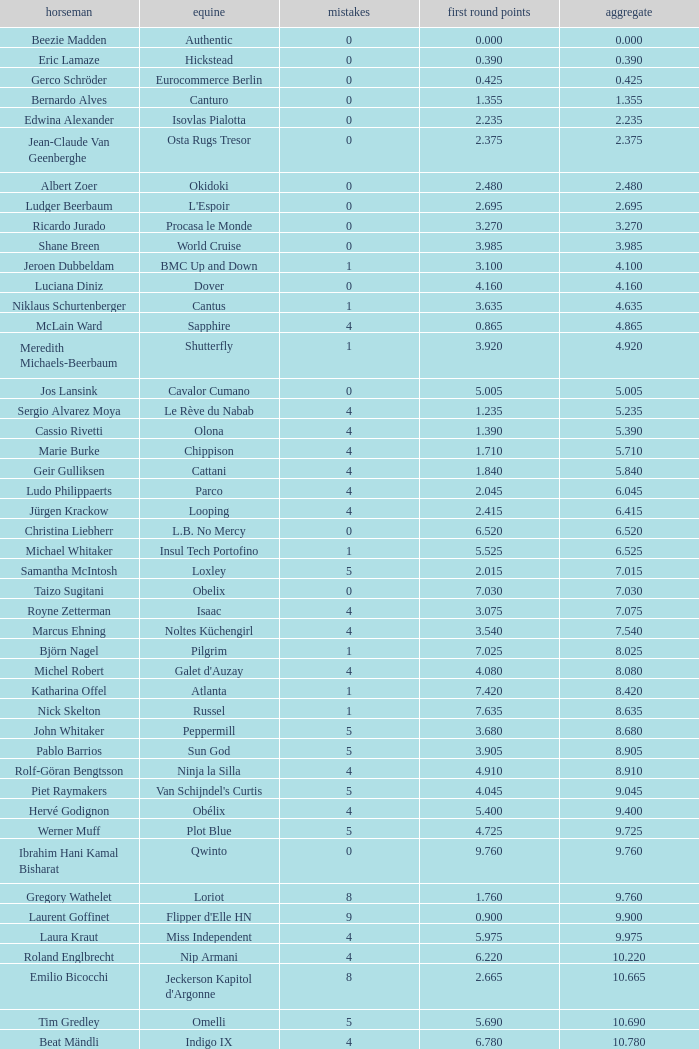Tell me the rider that had round 1 points of 7.465 and total more than 16.615 Manuel Fernandez Saro. 